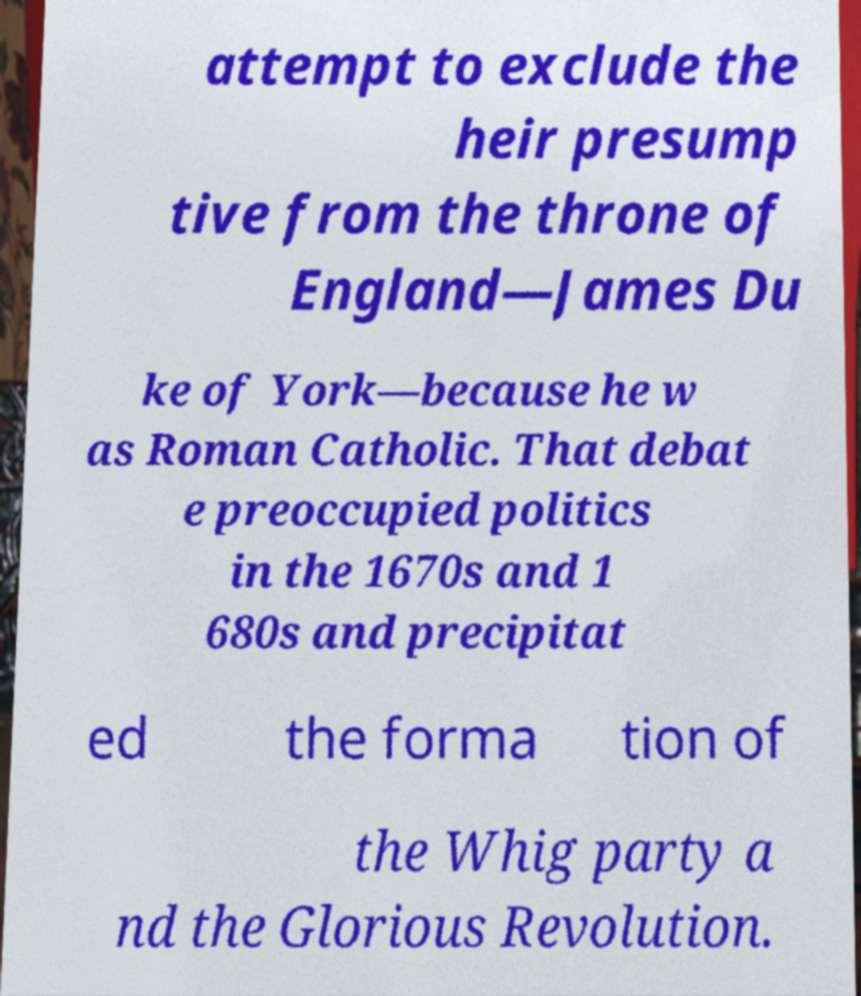Could you extract and type out the text from this image? attempt to exclude the heir presump tive from the throne of England—James Du ke of York—because he w as Roman Catholic. That debat e preoccupied politics in the 1670s and 1 680s and precipitat ed the forma tion of the Whig party a nd the Glorious Revolution. 